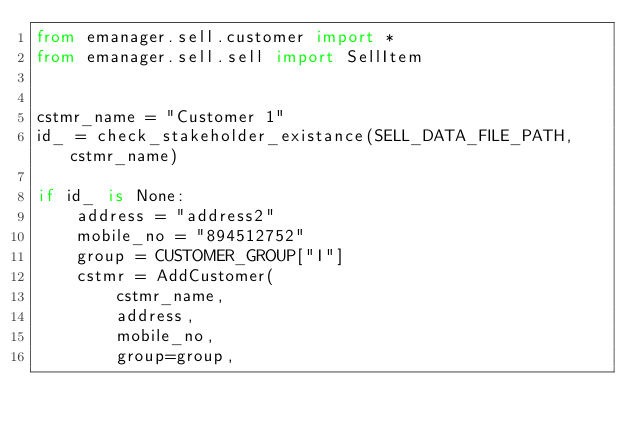Convert code to text. <code><loc_0><loc_0><loc_500><loc_500><_Python_>from emanager.sell.customer import *
from emanager.sell.sell import SellItem


cstmr_name = "Customer 1"
id_ = check_stakeholder_existance(SELL_DATA_FILE_PATH, cstmr_name)

if id_ is None:
    address = "address2"
    mobile_no = "894512752"
    group = CUSTOMER_GROUP["I"]
    cstmr = AddCustomer(
        cstmr_name,
        address,
        mobile_no,
        group=group,</code> 